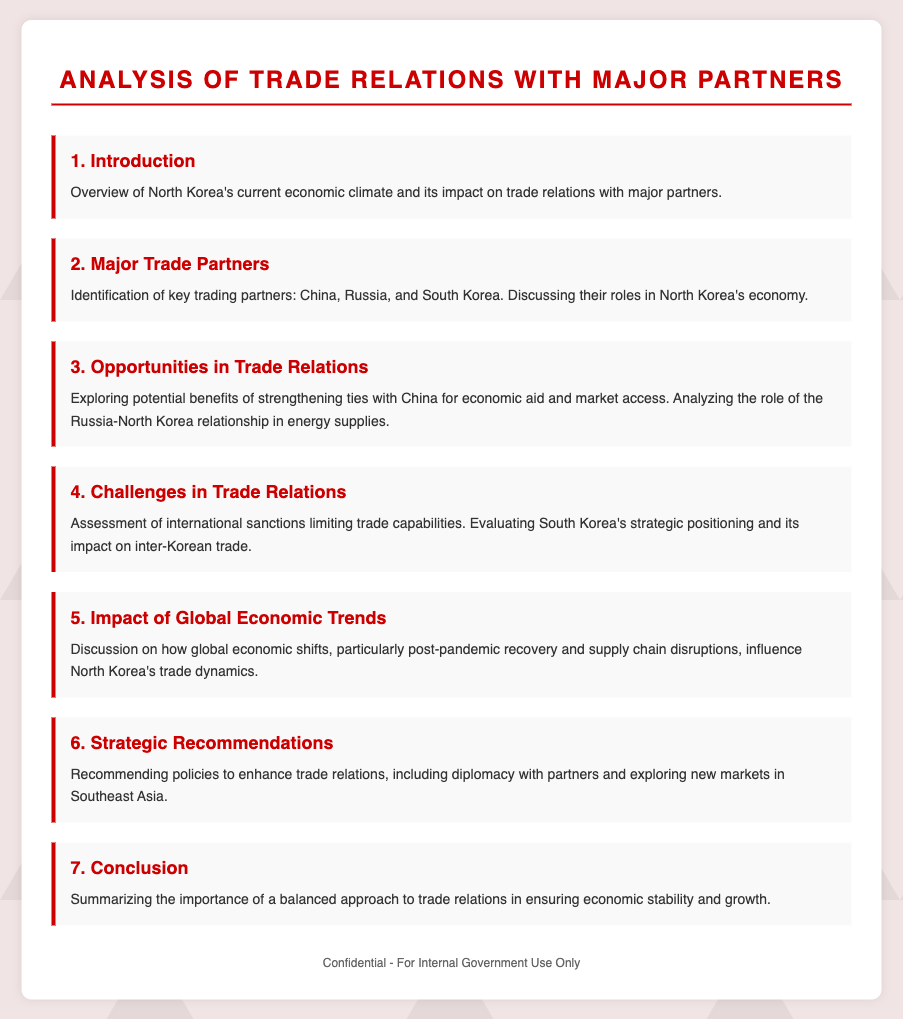What is the title of the document? The title is stated prominently at the top of the document.
Answer: Analysis of Trade Relations with Major Partners Who are the major trade partners mentioned? The section identifies key trading partners in North Korea's economy.
Answer: China, Russia, and South Korea What opportunities are explored in trade relations? The document discusses potential benefits of strengthening ties specifically.
Answer: Economic aid and market access What challenges in trade relations are assessed? It evaluates specific limitations that affect North Korea's trade capabilities.
Answer: International sanctions How many agenda items are listed in the document? The document outlines several key topics pertaining to trade relations.
Answer: Seven What is the focus of the conclusion? The conclusion summarizes a specific approach regarding trade relations.
Answer: Economic stability and growth Which global event impacts North Korea's trade dynamics? This section discusses how a significant global event affects trade.
Answer: Post-pandemic recovery 